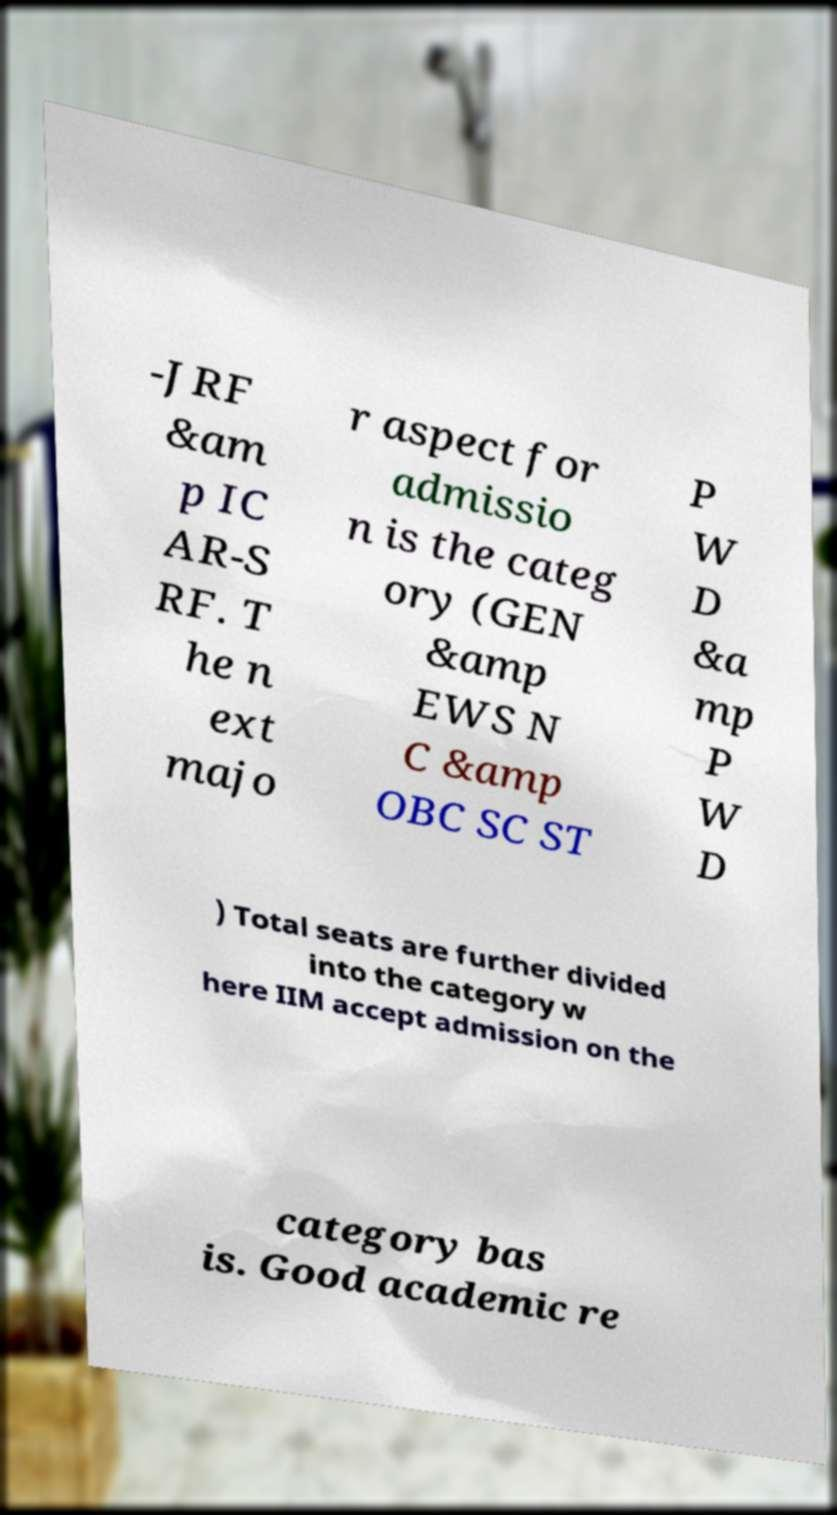I need the written content from this picture converted into text. Can you do that? -JRF &am p IC AR-S RF. T he n ext majo r aspect for admissio n is the categ ory (GEN &amp EWS N C &amp OBC SC ST P W D &a mp P W D ) Total seats are further divided into the category w here IIM accept admission on the category bas is. Good academic re 